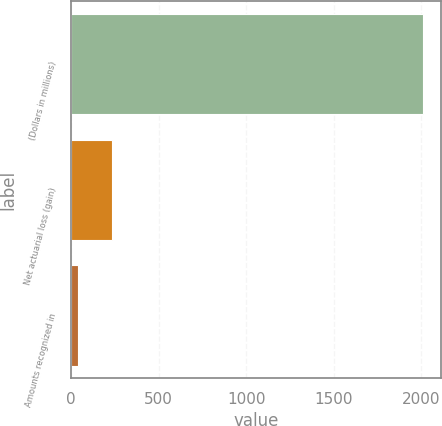<chart> <loc_0><loc_0><loc_500><loc_500><bar_chart><fcel>(Dollars in millions)<fcel>Net actuarial loss (gain)<fcel>Amounts recognized in<nl><fcel>2014<fcel>233.8<fcel>36<nl></chart> 